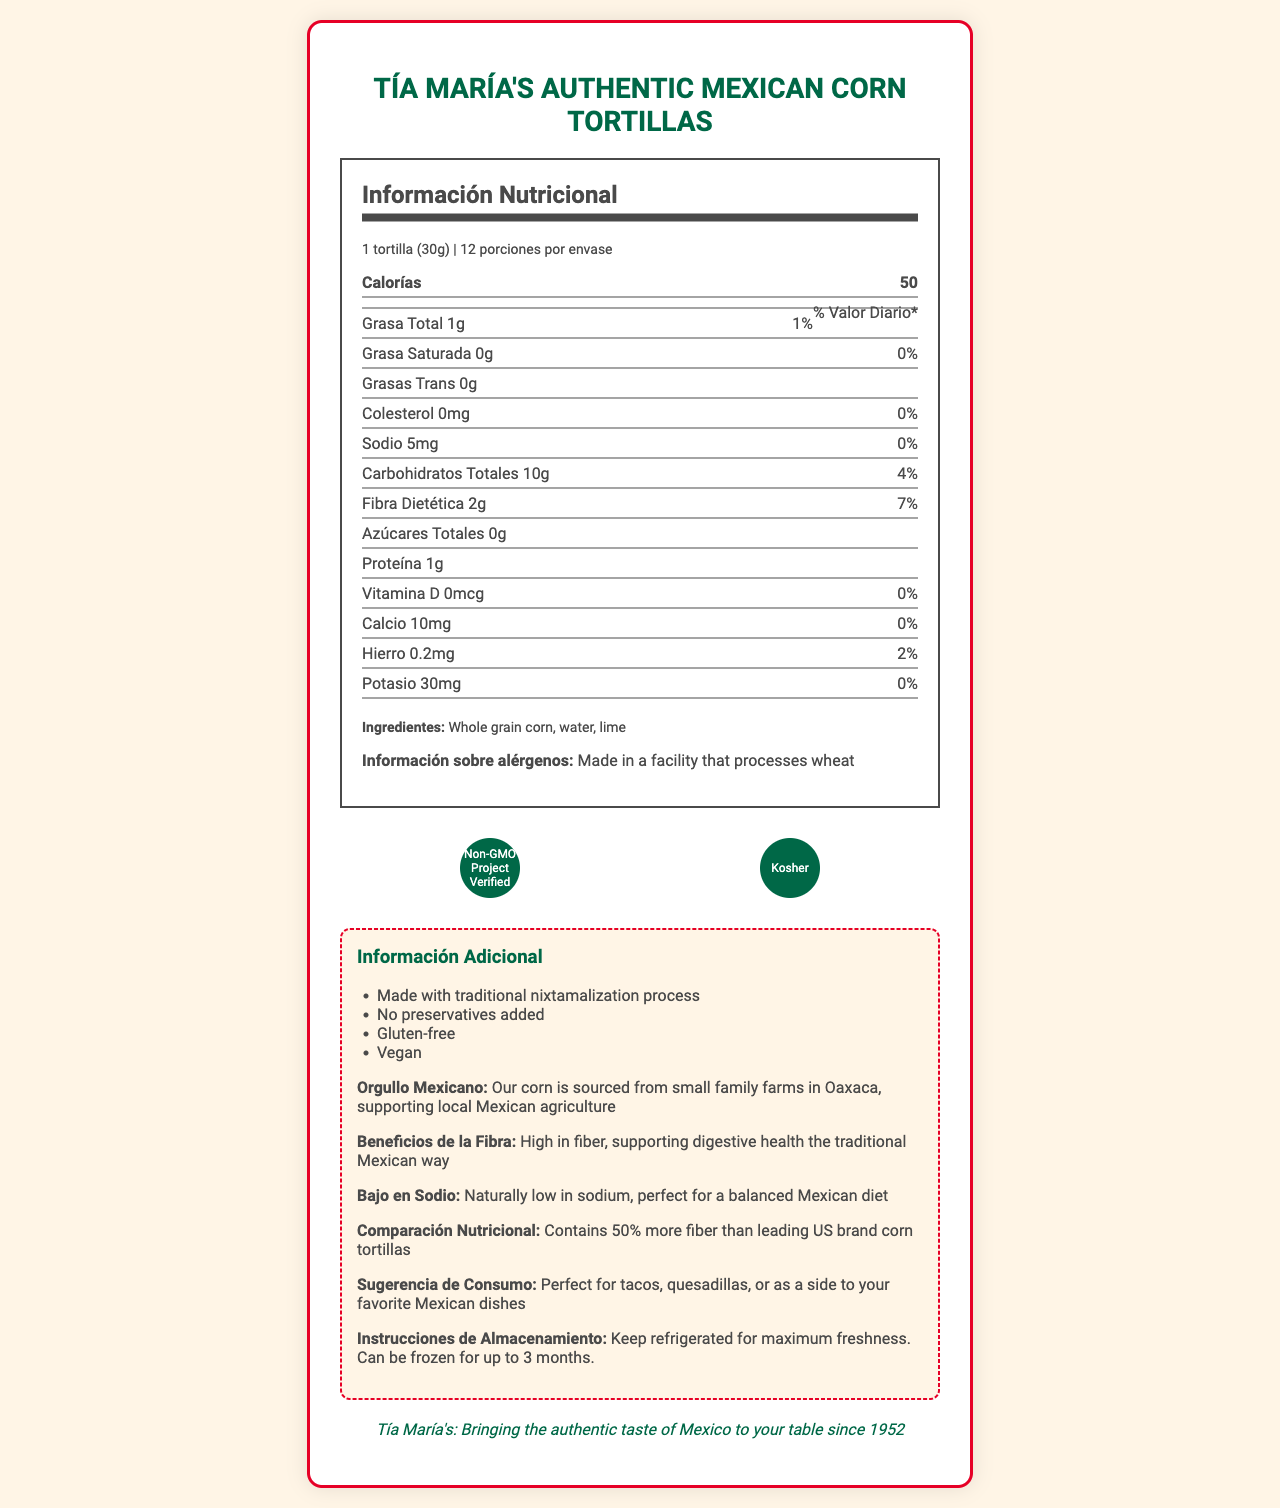what is the serving size for Tía María's Authentic Mexican Corn Tortillas? The serving size is specified as "1 tortilla (30g)" on the Nutrition Facts Label.
Answer: 1 tortilla (30g) how many servings are in one container? The label indicates "12 servings per container."
Answer: 12 how many calories are in one serving? The label specifies "Calorías 50."
Answer: 50 what is the amount of dietary fiber per serving? The dietary fiber content is clearly listed as "Fibra Dietética 2g" on the label.
Answer: 2g what is the percentage daily value of dietary fiber per serving? The percentage daily value for dietary fiber is "7%" as shown on the label.
Answer: 7% what is the sodium content per serving? The sodium content per serving is listed as "Sodio 5mg" on the label.
Answer: 5mg is the product low in sodium? The product is described as "Naturally low in sodium" in the additional information section.
Answer: Yes does this product contain any preservatives? The product states "No preservatives added" in the additional information section.
Answer: No does the product contain any Vitamin D? Both the amount, "0mcg," and the percent daily value, "0%," for Vitamin D are listed as zero on the label.
Answer: No which ingredient is not used in Tía María's Authentic Mexican Corn Tortillas? A. Whole grain corn B. Water C. Lime D. Salt The ingredients are listed as "Whole grain corn, water, lime," and do not include salt.
Answer: D. Salt how much protein is there in one tortilla? A. 1g B. 2g C. 3g D. 4g The protein content is listed as "Proteína 1g."
Answer: A. 1g what is the amount of calcium in one serving? A. 0mg B. 10mg C. 20mg D. 30mg The calcium content per serving is listed as "Calcio 10mg."
Answer: B. 10mg is the product gluten-free? This is mentioned in the additional information: "Gluten-free."
Answer: Yes describe the main idea of the Nutrition Facts Label for Tía María's Authentic Mexican Corn Tortillas The label aims to convey the nutritional benefits of the tortillas, emphasizing aspects such as high fiber and low sodium, along with additional information about ingredients, allergen details, and storage instructions. The brand's commitment to traditional methods and support of local Mexican agriculture is also underscored.
Answer: The document provides detailed nutritional information for Tía María's Authentic Mexican Corn Tortillas, including serving size, calorie content, macronutrients, vitamins, and minerals. It highlights the high fiber content, low sodium levels, traditional nixtamalization process, and the product's vegan and gluten-free certifications. how does the fiber content in Tía María's Tortillas compare to leading US brands? The nutritional comparison states, "Contains 50% more fiber than leading US brand corn tortillas."
Answer: It contains 50% more fiber. can you determine the specific farms in Oaxaca from which the corn is sourced? The label mentions that the corn is sourced from small family farms in Oaxaca but does not specify the exact farms.
Answer: Not enough information does the product have Kosher certification? The label includes "Kosher" as one of its certifications.
Answer: Yes what process is used to make Tía María's Tortillas traditional? The label mentions "Made with traditional nixtamalization process" in the additional information section.
Answer: Nixtamalization process 